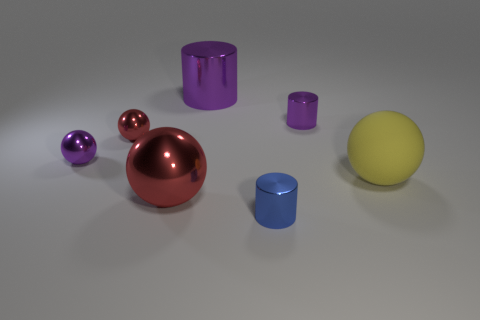Subtract 1 balls. How many balls are left? 3 Add 2 big matte things. How many objects exist? 9 Subtract all cylinders. How many objects are left? 4 Subtract 0 cyan balls. How many objects are left? 7 Subtract all tiny red metal balls. Subtract all purple spheres. How many objects are left? 5 Add 7 big rubber spheres. How many big rubber spheres are left? 8 Add 2 big purple shiny things. How many big purple shiny things exist? 3 